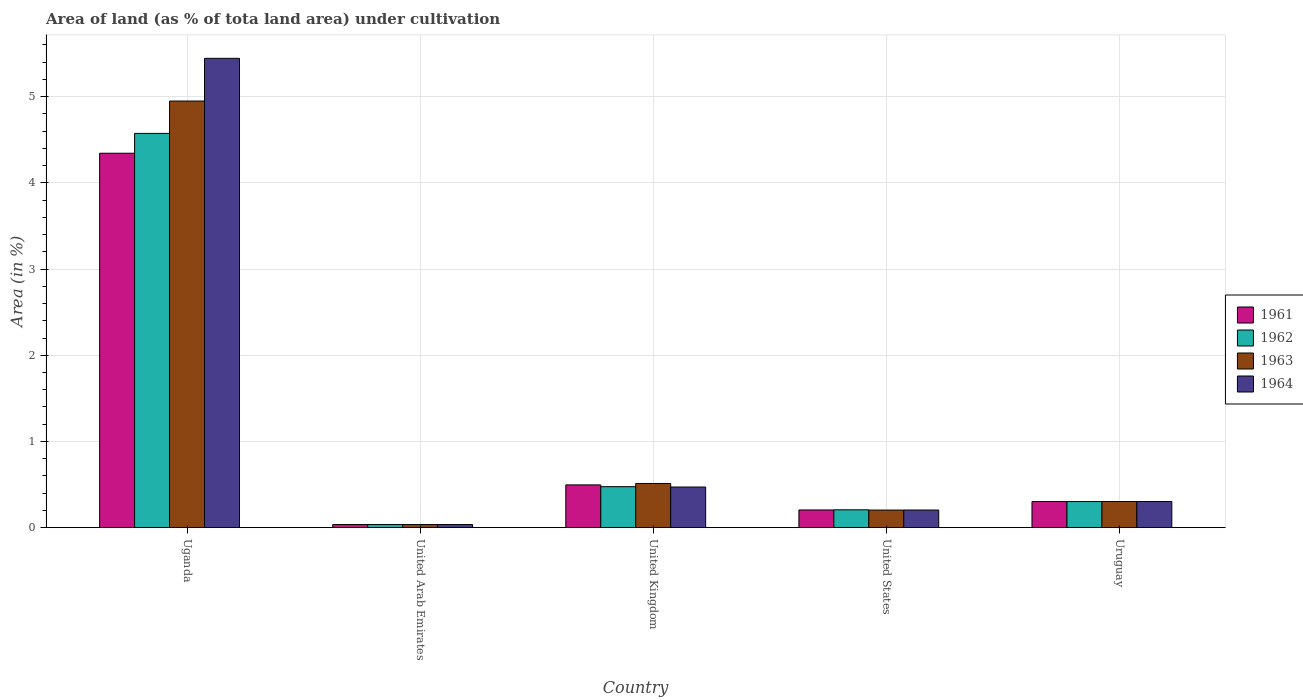How many different coloured bars are there?
Give a very brief answer. 4. How many bars are there on the 2nd tick from the left?
Make the answer very short. 4. What is the label of the 2nd group of bars from the left?
Your answer should be very brief. United Arab Emirates. In how many cases, is the number of bars for a given country not equal to the number of legend labels?
Provide a short and direct response. 0. What is the percentage of land under cultivation in 1961 in United Kingdom?
Make the answer very short. 0.5. Across all countries, what is the maximum percentage of land under cultivation in 1964?
Your response must be concise. 5.45. Across all countries, what is the minimum percentage of land under cultivation in 1962?
Offer a terse response. 0.04. In which country was the percentage of land under cultivation in 1961 maximum?
Ensure brevity in your answer.  Uganda. In which country was the percentage of land under cultivation in 1961 minimum?
Your answer should be compact. United Arab Emirates. What is the total percentage of land under cultivation in 1962 in the graph?
Ensure brevity in your answer.  5.6. What is the difference between the percentage of land under cultivation in 1963 in Uganda and that in United Kingdom?
Ensure brevity in your answer.  4.44. What is the difference between the percentage of land under cultivation in 1964 in United Kingdom and the percentage of land under cultivation in 1961 in Uganda?
Your response must be concise. -3.87. What is the average percentage of land under cultivation in 1963 per country?
Provide a succinct answer. 1.2. In how many countries, is the percentage of land under cultivation in 1963 greater than 2.4 %?
Give a very brief answer. 1. What is the ratio of the percentage of land under cultivation in 1964 in United Arab Emirates to that in United States?
Your response must be concise. 0.18. Is the percentage of land under cultivation in 1962 in United Arab Emirates less than that in United Kingdom?
Offer a very short reply. Yes. Is the difference between the percentage of land under cultivation in 1961 in Uganda and United States greater than the difference between the percentage of land under cultivation in 1962 in Uganda and United States?
Provide a short and direct response. No. What is the difference between the highest and the second highest percentage of land under cultivation in 1961?
Offer a very short reply. 0.19. What is the difference between the highest and the lowest percentage of land under cultivation in 1961?
Offer a terse response. 4.31. Is the sum of the percentage of land under cultivation in 1962 in United Kingdom and United States greater than the maximum percentage of land under cultivation in 1961 across all countries?
Offer a very short reply. No. Is it the case that in every country, the sum of the percentage of land under cultivation in 1964 and percentage of land under cultivation in 1962 is greater than the sum of percentage of land under cultivation in 1961 and percentage of land under cultivation in 1963?
Offer a very short reply. No. What does the 3rd bar from the right in Uruguay represents?
Provide a short and direct response. 1962. Is it the case that in every country, the sum of the percentage of land under cultivation in 1964 and percentage of land under cultivation in 1962 is greater than the percentage of land under cultivation in 1963?
Your response must be concise. Yes. How many bars are there?
Your answer should be very brief. 20. How many countries are there in the graph?
Your answer should be very brief. 5. What is the difference between two consecutive major ticks on the Y-axis?
Provide a short and direct response. 1. How are the legend labels stacked?
Provide a short and direct response. Vertical. What is the title of the graph?
Your response must be concise. Area of land (as % of tota land area) under cultivation. Does "1973" appear as one of the legend labels in the graph?
Give a very brief answer. No. What is the label or title of the X-axis?
Your response must be concise. Country. What is the label or title of the Y-axis?
Provide a short and direct response. Area (in %). What is the Area (in %) in 1961 in Uganda?
Your response must be concise. 4.34. What is the Area (in %) in 1962 in Uganda?
Keep it short and to the point. 4.57. What is the Area (in %) in 1963 in Uganda?
Keep it short and to the point. 4.95. What is the Area (in %) of 1964 in Uganda?
Your response must be concise. 5.45. What is the Area (in %) in 1961 in United Arab Emirates?
Ensure brevity in your answer.  0.04. What is the Area (in %) of 1962 in United Arab Emirates?
Ensure brevity in your answer.  0.04. What is the Area (in %) in 1963 in United Arab Emirates?
Provide a succinct answer. 0.04. What is the Area (in %) of 1964 in United Arab Emirates?
Keep it short and to the point. 0.04. What is the Area (in %) in 1961 in United Kingdom?
Offer a terse response. 0.5. What is the Area (in %) of 1962 in United Kingdom?
Offer a terse response. 0.48. What is the Area (in %) in 1963 in United Kingdom?
Keep it short and to the point. 0.51. What is the Area (in %) of 1964 in United Kingdom?
Offer a terse response. 0.47. What is the Area (in %) of 1961 in United States?
Provide a succinct answer. 0.21. What is the Area (in %) of 1962 in United States?
Your response must be concise. 0.21. What is the Area (in %) in 1963 in United States?
Keep it short and to the point. 0.2. What is the Area (in %) of 1964 in United States?
Provide a short and direct response. 0.2. What is the Area (in %) of 1961 in Uruguay?
Your answer should be compact. 0.3. What is the Area (in %) of 1962 in Uruguay?
Your response must be concise. 0.3. What is the Area (in %) of 1963 in Uruguay?
Ensure brevity in your answer.  0.3. What is the Area (in %) in 1964 in Uruguay?
Ensure brevity in your answer.  0.3. Across all countries, what is the maximum Area (in %) of 1961?
Offer a terse response. 4.34. Across all countries, what is the maximum Area (in %) of 1962?
Offer a terse response. 4.57. Across all countries, what is the maximum Area (in %) of 1963?
Your answer should be compact. 4.95. Across all countries, what is the maximum Area (in %) of 1964?
Ensure brevity in your answer.  5.45. Across all countries, what is the minimum Area (in %) in 1961?
Your response must be concise. 0.04. Across all countries, what is the minimum Area (in %) in 1962?
Your response must be concise. 0.04. Across all countries, what is the minimum Area (in %) in 1963?
Provide a short and direct response. 0.04. Across all countries, what is the minimum Area (in %) of 1964?
Your answer should be very brief. 0.04. What is the total Area (in %) in 1961 in the graph?
Your answer should be very brief. 5.38. What is the total Area (in %) in 1962 in the graph?
Make the answer very short. 5.6. What is the total Area (in %) of 1963 in the graph?
Provide a short and direct response. 6. What is the total Area (in %) of 1964 in the graph?
Your answer should be very brief. 6.46. What is the difference between the Area (in %) of 1961 in Uganda and that in United Arab Emirates?
Keep it short and to the point. 4.31. What is the difference between the Area (in %) of 1962 in Uganda and that in United Arab Emirates?
Your answer should be compact. 4.54. What is the difference between the Area (in %) in 1963 in Uganda and that in United Arab Emirates?
Offer a very short reply. 4.91. What is the difference between the Area (in %) in 1964 in Uganda and that in United Arab Emirates?
Offer a terse response. 5.41. What is the difference between the Area (in %) of 1961 in Uganda and that in United Kingdom?
Your answer should be very brief. 3.85. What is the difference between the Area (in %) in 1962 in Uganda and that in United Kingdom?
Provide a succinct answer. 4.1. What is the difference between the Area (in %) in 1963 in Uganda and that in United Kingdom?
Your response must be concise. 4.44. What is the difference between the Area (in %) in 1964 in Uganda and that in United Kingdom?
Provide a short and direct response. 4.97. What is the difference between the Area (in %) in 1961 in Uganda and that in United States?
Provide a short and direct response. 4.14. What is the difference between the Area (in %) of 1962 in Uganda and that in United States?
Your answer should be compact. 4.37. What is the difference between the Area (in %) of 1963 in Uganda and that in United States?
Ensure brevity in your answer.  4.75. What is the difference between the Area (in %) of 1964 in Uganda and that in United States?
Offer a very short reply. 5.24. What is the difference between the Area (in %) in 1961 in Uganda and that in Uruguay?
Ensure brevity in your answer.  4.04. What is the difference between the Area (in %) in 1962 in Uganda and that in Uruguay?
Your response must be concise. 4.27. What is the difference between the Area (in %) of 1963 in Uganda and that in Uruguay?
Provide a succinct answer. 4.65. What is the difference between the Area (in %) in 1964 in Uganda and that in Uruguay?
Provide a short and direct response. 5.14. What is the difference between the Area (in %) of 1961 in United Arab Emirates and that in United Kingdom?
Your answer should be compact. -0.46. What is the difference between the Area (in %) in 1962 in United Arab Emirates and that in United Kingdom?
Give a very brief answer. -0.44. What is the difference between the Area (in %) in 1963 in United Arab Emirates and that in United Kingdom?
Keep it short and to the point. -0.48. What is the difference between the Area (in %) of 1964 in United Arab Emirates and that in United Kingdom?
Offer a very short reply. -0.44. What is the difference between the Area (in %) in 1961 in United Arab Emirates and that in United States?
Keep it short and to the point. -0.17. What is the difference between the Area (in %) of 1962 in United Arab Emirates and that in United States?
Make the answer very short. -0.17. What is the difference between the Area (in %) of 1963 in United Arab Emirates and that in United States?
Your answer should be very brief. -0.17. What is the difference between the Area (in %) of 1964 in United Arab Emirates and that in United States?
Offer a terse response. -0.17. What is the difference between the Area (in %) of 1961 in United Arab Emirates and that in Uruguay?
Offer a terse response. -0.27. What is the difference between the Area (in %) of 1962 in United Arab Emirates and that in Uruguay?
Your response must be concise. -0.27. What is the difference between the Area (in %) in 1963 in United Arab Emirates and that in Uruguay?
Your answer should be very brief. -0.27. What is the difference between the Area (in %) in 1964 in United Arab Emirates and that in Uruguay?
Your answer should be compact. -0.27. What is the difference between the Area (in %) in 1961 in United Kingdom and that in United States?
Provide a short and direct response. 0.29. What is the difference between the Area (in %) in 1962 in United Kingdom and that in United States?
Provide a short and direct response. 0.27. What is the difference between the Area (in %) in 1963 in United Kingdom and that in United States?
Keep it short and to the point. 0.31. What is the difference between the Area (in %) in 1964 in United Kingdom and that in United States?
Provide a succinct answer. 0.27. What is the difference between the Area (in %) of 1961 in United Kingdom and that in Uruguay?
Your answer should be compact. 0.19. What is the difference between the Area (in %) in 1962 in United Kingdom and that in Uruguay?
Offer a terse response. 0.17. What is the difference between the Area (in %) of 1963 in United Kingdom and that in Uruguay?
Your answer should be compact. 0.21. What is the difference between the Area (in %) of 1964 in United Kingdom and that in Uruguay?
Provide a succinct answer. 0.17. What is the difference between the Area (in %) in 1961 in United States and that in Uruguay?
Offer a very short reply. -0.1. What is the difference between the Area (in %) in 1962 in United States and that in Uruguay?
Offer a very short reply. -0.1. What is the difference between the Area (in %) of 1963 in United States and that in Uruguay?
Offer a terse response. -0.1. What is the difference between the Area (in %) of 1964 in United States and that in Uruguay?
Provide a succinct answer. -0.1. What is the difference between the Area (in %) in 1961 in Uganda and the Area (in %) in 1962 in United Arab Emirates?
Provide a succinct answer. 4.31. What is the difference between the Area (in %) of 1961 in Uganda and the Area (in %) of 1963 in United Arab Emirates?
Provide a short and direct response. 4.31. What is the difference between the Area (in %) of 1961 in Uganda and the Area (in %) of 1964 in United Arab Emirates?
Your answer should be compact. 4.31. What is the difference between the Area (in %) of 1962 in Uganda and the Area (in %) of 1963 in United Arab Emirates?
Your answer should be very brief. 4.54. What is the difference between the Area (in %) in 1962 in Uganda and the Area (in %) in 1964 in United Arab Emirates?
Your answer should be very brief. 4.54. What is the difference between the Area (in %) in 1963 in Uganda and the Area (in %) in 1964 in United Arab Emirates?
Provide a short and direct response. 4.91. What is the difference between the Area (in %) of 1961 in Uganda and the Area (in %) of 1962 in United Kingdom?
Your response must be concise. 3.87. What is the difference between the Area (in %) in 1961 in Uganda and the Area (in %) in 1963 in United Kingdom?
Provide a succinct answer. 3.83. What is the difference between the Area (in %) in 1961 in Uganda and the Area (in %) in 1964 in United Kingdom?
Offer a very short reply. 3.87. What is the difference between the Area (in %) of 1962 in Uganda and the Area (in %) of 1963 in United Kingdom?
Offer a very short reply. 4.06. What is the difference between the Area (in %) in 1962 in Uganda and the Area (in %) in 1964 in United Kingdom?
Make the answer very short. 4.1. What is the difference between the Area (in %) in 1963 in Uganda and the Area (in %) in 1964 in United Kingdom?
Your answer should be very brief. 4.48. What is the difference between the Area (in %) of 1961 in Uganda and the Area (in %) of 1962 in United States?
Give a very brief answer. 4.14. What is the difference between the Area (in %) of 1961 in Uganda and the Area (in %) of 1963 in United States?
Ensure brevity in your answer.  4.14. What is the difference between the Area (in %) in 1961 in Uganda and the Area (in %) in 1964 in United States?
Give a very brief answer. 4.14. What is the difference between the Area (in %) of 1962 in Uganda and the Area (in %) of 1963 in United States?
Keep it short and to the point. 4.37. What is the difference between the Area (in %) in 1962 in Uganda and the Area (in %) in 1964 in United States?
Ensure brevity in your answer.  4.37. What is the difference between the Area (in %) of 1963 in Uganda and the Area (in %) of 1964 in United States?
Provide a succinct answer. 4.75. What is the difference between the Area (in %) in 1961 in Uganda and the Area (in %) in 1962 in Uruguay?
Offer a very short reply. 4.04. What is the difference between the Area (in %) of 1961 in Uganda and the Area (in %) of 1963 in Uruguay?
Make the answer very short. 4.04. What is the difference between the Area (in %) in 1961 in Uganda and the Area (in %) in 1964 in Uruguay?
Provide a succinct answer. 4.04. What is the difference between the Area (in %) of 1962 in Uganda and the Area (in %) of 1963 in Uruguay?
Make the answer very short. 4.27. What is the difference between the Area (in %) of 1962 in Uganda and the Area (in %) of 1964 in Uruguay?
Make the answer very short. 4.27. What is the difference between the Area (in %) of 1963 in Uganda and the Area (in %) of 1964 in Uruguay?
Offer a terse response. 4.65. What is the difference between the Area (in %) of 1961 in United Arab Emirates and the Area (in %) of 1962 in United Kingdom?
Keep it short and to the point. -0.44. What is the difference between the Area (in %) of 1961 in United Arab Emirates and the Area (in %) of 1963 in United Kingdom?
Make the answer very short. -0.48. What is the difference between the Area (in %) in 1961 in United Arab Emirates and the Area (in %) in 1964 in United Kingdom?
Your answer should be compact. -0.44. What is the difference between the Area (in %) in 1962 in United Arab Emirates and the Area (in %) in 1963 in United Kingdom?
Your response must be concise. -0.48. What is the difference between the Area (in %) in 1962 in United Arab Emirates and the Area (in %) in 1964 in United Kingdom?
Your response must be concise. -0.44. What is the difference between the Area (in %) of 1963 in United Arab Emirates and the Area (in %) of 1964 in United Kingdom?
Provide a short and direct response. -0.44. What is the difference between the Area (in %) in 1961 in United Arab Emirates and the Area (in %) in 1962 in United States?
Ensure brevity in your answer.  -0.17. What is the difference between the Area (in %) in 1961 in United Arab Emirates and the Area (in %) in 1963 in United States?
Provide a short and direct response. -0.17. What is the difference between the Area (in %) of 1961 in United Arab Emirates and the Area (in %) of 1964 in United States?
Your answer should be very brief. -0.17. What is the difference between the Area (in %) in 1962 in United Arab Emirates and the Area (in %) in 1963 in United States?
Provide a succinct answer. -0.17. What is the difference between the Area (in %) of 1962 in United Arab Emirates and the Area (in %) of 1964 in United States?
Your answer should be very brief. -0.17. What is the difference between the Area (in %) in 1963 in United Arab Emirates and the Area (in %) in 1964 in United States?
Provide a short and direct response. -0.17. What is the difference between the Area (in %) in 1961 in United Arab Emirates and the Area (in %) in 1962 in Uruguay?
Your response must be concise. -0.27. What is the difference between the Area (in %) of 1961 in United Arab Emirates and the Area (in %) of 1963 in Uruguay?
Make the answer very short. -0.27. What is the difference between the Area (in %) of 1961 in United Arab Emirates and the Area (in %) of 1964 in Uruguay?
Keep it short and to the point. -0.27. What is the difference between the Area (in %) in 1962 in United Arab Emirates and the Area (in %) in 1963 in Uruguay?
Make the answer very short. -0.27. What is the difference between the Area (in %) in 1962 in United Arab Emirates and the Area (in %) in 1964 in Uruguay?
Provide a succinct answer. -0.27. What is the difference between the Area (in %) in 1963 in United Arab Emirates and the Area (in %) in 1964 in Uruguay?
Provide a succinct answer. -0.27. What is the difference between the Area (in %) in 1961 in United Kingdom and the Area (in %) in 1962 in United States?
Make the answer very short. 0.29. What is the difference between the Area (in %) of 1961 in United Kingdom and the Area (in %) of 1963 in United States?
Make the answer very short. 0.29. What is the difference between the Area (in %) in 1961 in United Kingdom and the Area (in %) in 1964 in United States?
Keep it short and to the point. 0.29. What is the difference between the Area (in %) of 1962 in United Kingdom and the Area (in %) of 1963 in United States?
Provide a short and direct response. 0.27. What is the difference between the Area (in %) of 1962 in United Kingdom and the Area (in %) of 1964 in United States?
Ensure brevity in your answer.  0.27. What is the difference between the Area (in %) of 1963 in United Kingdom and the Area (in %) of 1964 in United States?
Provide a short and direct response. 0.31. What is the difference between the Area (in %) in 1961 in United Kingdom and the Area (in %) in 1962 in Uruguay?
Give a very brief answer. 0.19. What is the difference between the Area (in %) of 1961 in United Kingdom and the Area (in %) of 1963 in Uruguay?
Make the answer very short. 0.19. What is the difference between the Area (in %) of 1961 in United Kingdom and the Area (in %) of 1964 in Uruguay?
Provide a short and direct response. 0.19. What is the difference between the Area (in %) of 1962 in United Kingdom and the Area (in %) of 1963 in Uruguay?
Make the answer very short. 0.17. What is the difference between the Area (in %) in 1962 in United Kingdom and the Area (in %) in 1964 in Uruguay?
Offer a very short reply. 0.17. What is the difference between the Area (in %) of 1963 in United Kingdom and the Area (in %) of 1964 in Uruguay?
Provide a short and direct response. 0.21. What is the difference between the Area (in %) of 1961 in United States and the Area (in %) of 1962 in Uruguay?
Give a very brief answer. -0.1. What is the difference between the Area (in %) of 1961 in United States and the Area (in %) of 1963 in Uruguay?
Your answer should be compact. -0.1. What is the difference between the Area (in %) of 1961 in United States and the Area (in %) of 1964 in Uruguay?
Ensure brevity in your answer.  -0.1. What is the difference between the Area (in %) in 1962 in United States and the Area (in %) in 1963 in Uruguay?
Provide a succinct answer. -0.1. What is the difference between the Area (in %) in 1962 in United States and the Area (in %) in 1964 in Uruguay?
Your response must be concise. -0.1. What is the difference between the Area (in %) of 1963 in United States and the Area (in %) of 1964 in Uruguay?
Give a very brief answer. -0.1. What is the average Area (in %) of 1961 per country?
Ensure brevity in your answer.  1.08. What is the average Area (in %) in 1962 per country?
Give a very brief answer. 1.12. What is the average Area (in %) in 1963 per country?
Offer a very short reply. 1.2. What is the average Area (in %) of 1964 per country?
Give a very brief answer. 1.29. What is the difference between the Area (in %) in 1961 and Area (in %) in 1962 in Uganda?
Keep it short and to the point. -0.23. What is the difference between the Area (in %) of 1961 and Area (in %) of 1963 in Uganda?
Keep it short and to the point. -0.61. What is the difference between the Area (in %) of 1961 and Area (in %) of 1964 in Uganda?
Make the answer very short. -1.1. What is the difference between the Area (in %) in 1962 and Area (in %) in 1963 in Uganda?
Ensure brevity in your answer.  -0.38. What is the difference between the Area (in %) of 1962 and Area (in %) of 1964 in Uganda?
Give a very brief answer. -0.87. What is the difference between the Area (in %) of 1963 and Area (in %) of 1964 in Uganda?
Provide a succinct answer. -0.5. What is the difference between the Area (in %) in 1963 and Area (in %) in 1964 in United Arab Emirates?
Your answer should be very brief. 0. What is the difference between the Area (in %) of 1961 and Area (in %) of 1962 in United Kingdom?
Your answer should be very brief. 0.02. What is the difference between the Area (in %) in 1961 and Area (in %) in 1963 in United Kingdom?
Ensure brevity in your answer.  -0.02. What is the difference between the Area (in %) of 1961 and Area (in %) of 1964 in United Kingdom?
Your response must be concise. 0.02. What is the difference between the Area (in %) in 1962 and Area (in %) in 1963 in United Kingdom?
Give a very brief answer. -0.04. What is the difference between the Area (in %) in 1962 and Area (in %) in 1964 in United Kingdom?
Your answer should be very brief. 0. What is the difference between the Area (in %) of 1963 and Area (in %) of 1964 in United Kingdom?
Ensure brevity in your answer.  0.04. What is the difference between the Area (in %) in 1961 and Area (in %) in 1962 in United States?
Make the answer very short. -0. What is the difference between the Area (in %) in 1961 and Area (in %) in 1963 in United States?
Offer a terse response. 0. What is the difference between the Area (in %) of 1961 and Area (in %) of 1964 in United States?
Your answer should be very brief. 0. What is the difference between the Area (in %) of 1962 and Area (in %) of 1963 in United States?
Ensure brevity in your answer.  0. What is the difference between the Area (in %) of 1962 and Area (in %) of 1964 in United States?
Make the answer very short. 0. What is the difference between the Area (in %) of 1963 and Area (in %) of 1964 in United States?
Give a very brief answer. -0. What is the difference between the Area (in %) in 1963 and Area (in %) in 1964 in Uruguay?
Give a very brief answer. 0. What is the ratio of the Area (in %) in 1961 in Uganda to that in United Arab Emirates?
Offer a terse response. 121.06. What is the ratio of the Area (in %) in 1962 in Uganda to that in United Arab Emirates?
Keep it short and to the point. 127.47. What is the ratio of the Area (in %) of 1963 in Uganda to that in United Arab Emirates?
Your response must be concise. 137.93. What is the ratio of the Area (in %) of 1964 in Uganda to that in United Arab Emirates?
Your response must be concise. 151.74. What is the ratio of the Area (in %) in 1961 in Uganda to that in United Kingdom?
Offer a very short reply. 8.76. What is the ratio of the Area (in %) of 1962 in Uganda to that in United Kingdom?
Offer a terse response. 9.62. What is the ratio of the Area (in %) in 1963 in Uganda to that in United Kingdom?
Keep it short and to the point. 9.66. What is the ratio of the Area (in %) in 1964 in Uganda to that in United Kingdom?
Your answer should be very brief. 11.56. What is the ratio of the Area (in %) of 1961 in Uganda to that in United States?
Your response must be concise. 21.17. What is the ratio of the Area (in %) in 1962 in Uganda to that in United States?
Your response must be concise. 22.1. What is the ratio of the Area (in %) of 1963 in Uganda to that in United States?
Offer a terse response. 24.26. What is the ratio of the Area (in %) of 1964 in Uganda to that in United States?
Keep it short and to the point. 26.63. What is the ratio of the Area (in %) of 1961 in Uganda to that in Uruguay?
Give a very brief answer. 14.35. What is the ratio of the Area (in %) of 1962 in Uganda to that in Uruguay?
Provide a short and direct response. 15.11. What is the ratio of the Area (in %) of 1963 in Uganda to that in Uruguay?
Provide a succinct answer. 16.35. What is the ratio of the Area (in %) in 1964 in Uganda to that in Uruguay?
Provide a succinct answer. 17.98. What is the ratio of the Area (in %) in 1961 in United Arab Emirates to that in United Kingdom?
Your answer should be very brief. 0.07. What is the ratio of the Area (in %) in 1962 in United Arab Emirates to that in United Kingdom?
Your answer should be very brief. 0.08. What is the ratio of the Area (in %) of 1963 in United Arab Emirates to that in United Kingdom?
Provide a succinct answer. 0.07. What is the ratio of the Area (in %) of 1964 in United Arab Emirates to that in United Kingdom?
Give a very brief answer. 0.08. What is the ratio of the Area (in %) in 1961 in United Arab Emirates to that in United States?
Provide a short and direct response. 0.17. What is the ratio of the Area (in %) of 1962 in United Arab Emirates to that in United States?
Offer a very short reply. 0.17. What is the ratio of the Area (in %) in 1963 in United Arab Emirates to that in United States?
Give a very brief answer. 0.18. What is the ratio of the Area (in %) of 1964 in United Arab Emirates to that in United States?
Your answer should be compact. 0.18. What is the ratio of the Area (in %) of 1961 in United Arab Emirates to that in Uruguay?
Ensure brevity in your answer.  0.12. What is the ratio of the Area (in %) in 1962 in United Arab Emirates to that in Uruguay?
Give a very brief answer. 0.12. What is the ratio of the Area (in %) of 1963 in United Arab Emirates to that in Uruguay?
Your answer should be very brief. 0.12. What is the ratio of the Area (in %) in 1964 in United Arab Emirates to that in Uruguay?
Ensure brevity in your answer.  0.12. What is the ratio of the Area (in %) in 1961 in United Kingdom to that in United States?
Ensure brevity in your answer.  2.42. What is the ratio of the Area (in %) in 1962 in United Kingdom to that in United States?
Your answer should be compact. 2.3. What is the ratio of the Area (in %) in 1963 in United Kingdom to that in United States?
Your response must be concise. 2.51. What is the ratio of the Area (in %) of 1964 in United Kingdom to that in United States?
Your response must be concise. 2.3. What is the ratio of the Area (in %) in 1961 in United Kingdom to that in Uruguay?
Your answer should be very brief. 1.64. What is the ratio of the Area (in %) of 1962 in United Kingdom to that in Uruguay?
Give a very brief answer. 1.57. What is the ratio of the Area (in %) of 1963 in United Kingdom to that in Uruguay?
Your answer should be compact. 1.69. What is the ratio of the Area (in %) in 1964 in United Kingdom to that in Uruguay?
Keep it short and to the point. 1.56. What is the ratio of the Area (in %) of 1961 in United States to that in Uruguay?
Ensure brevity in your answer.  0.68. What is the ratio of the Area (in %) in 1962 in United States to that in Uruguay?
Give a very brief answer. 0.68. What is the ratio of the Area (in %) in 1963 in United States to that in Uruguay?
Keep it short and to the point. 0.67. What is the ratio of the Area (in %) of 1964 in United States to that in Uruguay?
Make the answer very short. 0.68. What is the difference between the highest and the second highest Area (in %) of 1961?
Your response must be concise. 3.85. What is the difference between the highest and the second highest Area (in %) of 1962?
Keep it short and to the point. 4.1. What is the difference between the highest and the second highest Area (in %) of 1963?
Your answer should be very brief. 4.44. What is the difference between the highest and the second highest Area (in %) of 1964?
Ensure brevity in your answer.  4.97. What is the difference between the highest and the lowest Area (in %) in 1961?
Provide a short and direct response. 4.31. What is the difference between the highest and the lowest Area (in %) of 1962?
Your answer should be very brief. 4.54. What is the difference between the highest and the lowest Area (in %) in 1963?
Provide a succinct answer. 4.91. What is the difference between the highest and the lowest Area (in %) in 1964?
Offer a very short reply. 5.41. 